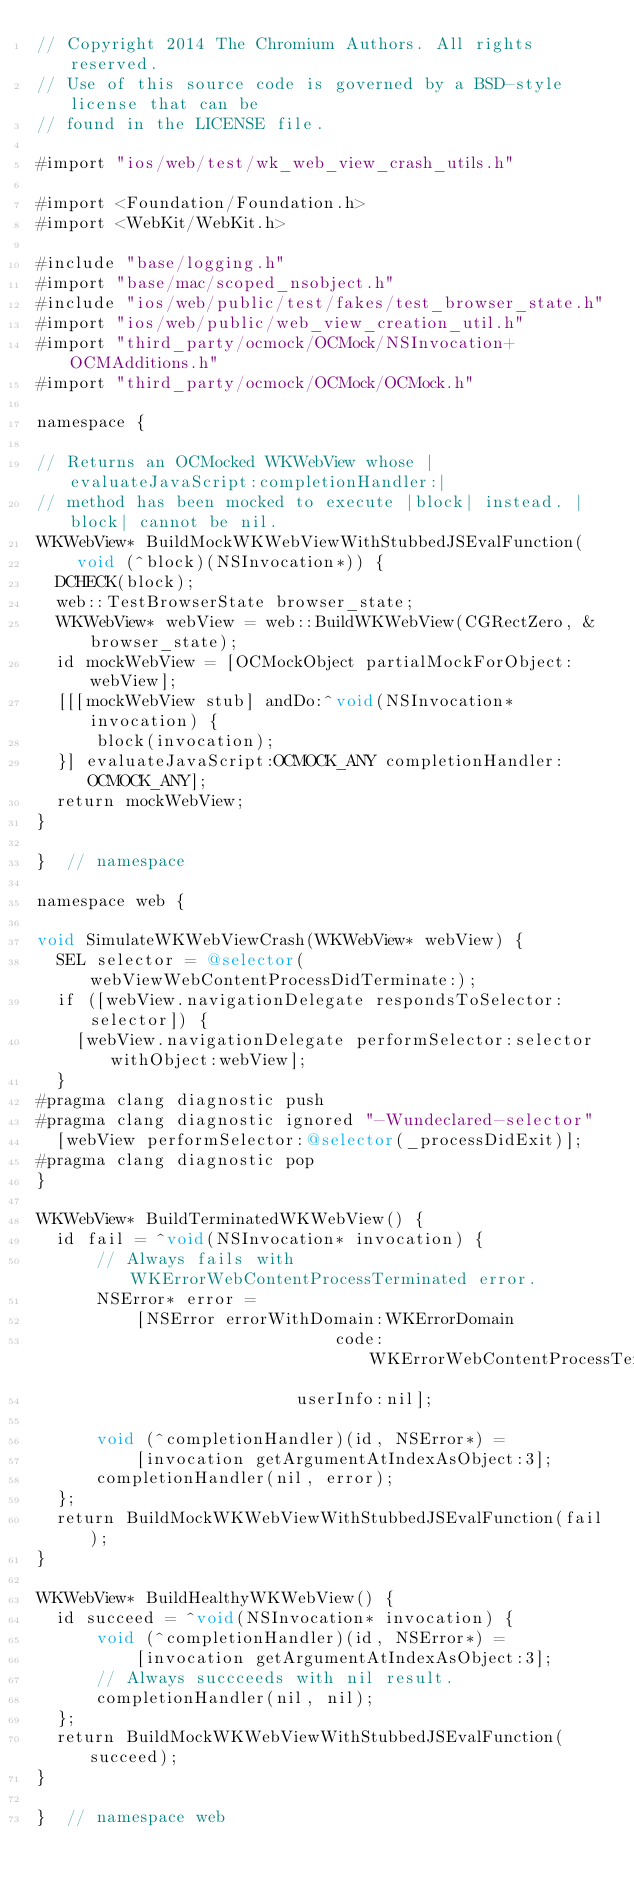<code> <loc_0><loc_0><loc_500><loc_500><_ObjectiveC_>// Copyright 2014 The Chromium Authors. All rights reserved.
// Use of this source code is governed by a BSD-style license that can be
// found in the LICENSE file.

#import "ios/web/test/wk_web_view_crash_utils.h"

#import <Foundation/Foundation.h>
#import <WebKit/WebKit.h>

#include "base/logging.h"
#import "base/mac/scoped_nsobject.h"
#include "ios/web/public/test/fakes/test_browser_state.h"
#import "ios/web/public/web_view_creation_util.h"
#import "third_party/ocmock/OCMock/NSInvocation+OCMAdditions.h"
#import "third_party/ocmock/OCMock/OCMock.h"

namespace {

// Returns an OCMocked WKWebView whose |evaluateJavaScript:completionHandler:|
// method has been mocked to execute |block| instead. |block| cannot be nil.
WKWebView* BuildMockWKWebViewWithStubbedJSEvalFunction(
    void (^block)(NSInvocation*)) {
  DCHECK(block);
  web::TestBrowserState browser_state;
  WKWebView* webView = web::BuildWKWebView(CGRectZero, &browser_state);
  id mockWebView = [OCMockObject partialMockForObject:webView];
  [[[mockWebView stub] andDo:^void(NSInvocation* invocation) {
      block(invocation);
  }] evaluateJavaScript:OCMOCK_ANY completionHandler:OCMOCK_ANY];
  return mockWebView;
}

}  // namespace

namespace web {

void SimulateWKWebViewCrash(WKWebView* webView) {
  SEL selector = @selector(webViewWebContentProcessDidTerminate:);
  if ([webView.navigationDelegate respondsToSelector:selector]) {
    [webView.navigationDelegate performSelector:selector withObject:webView];
  }
#pragma clang diagnostic push
#pragma clang diagnostic ignored "-Wundeclared-selector"
  [webView performSelector:@selector(_processDidExit)];
#pragma clang diagnostic pop
}

WKWebView* BuildTerminatedWKWebView() {
  id fail = ^void(NSInvocation* invocation) {
      // Always fails with WKErrorWebContentProcessTerminated error.
      NSError* error =
          [NSError errorWithDomain:WKErrorDomain
                              code:WKErrorWebContentProcessTerminated
                          userInfo:nil];

      void (^completionHandler)(id, NSError*) =
          [invocation getArgumentAtIndexAsObject:3];
      completionHandler(nil, error);
  };
  return BuildMockWKWebViewWithStubbedJSEvalFunction(fail);
}

WKWebView* BuildHealthyWKWebView() {
  id succeed = ^void(NSInvocation* invocation) {
      void (^completionHandler)(id, NSError*) =
          [invocation getArgumentAtIndexAsObject:3];
      // Always succceeds with nil result.
      completionHandler(nil, nil);
  };
  return BuildMockWKWebViewWithStubbedJSEvalFunction(succeed);
}

}  // namespace web
</code> 